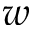<formula> <loc_0><loc_0><loc_500><loc_500>w</formula> 